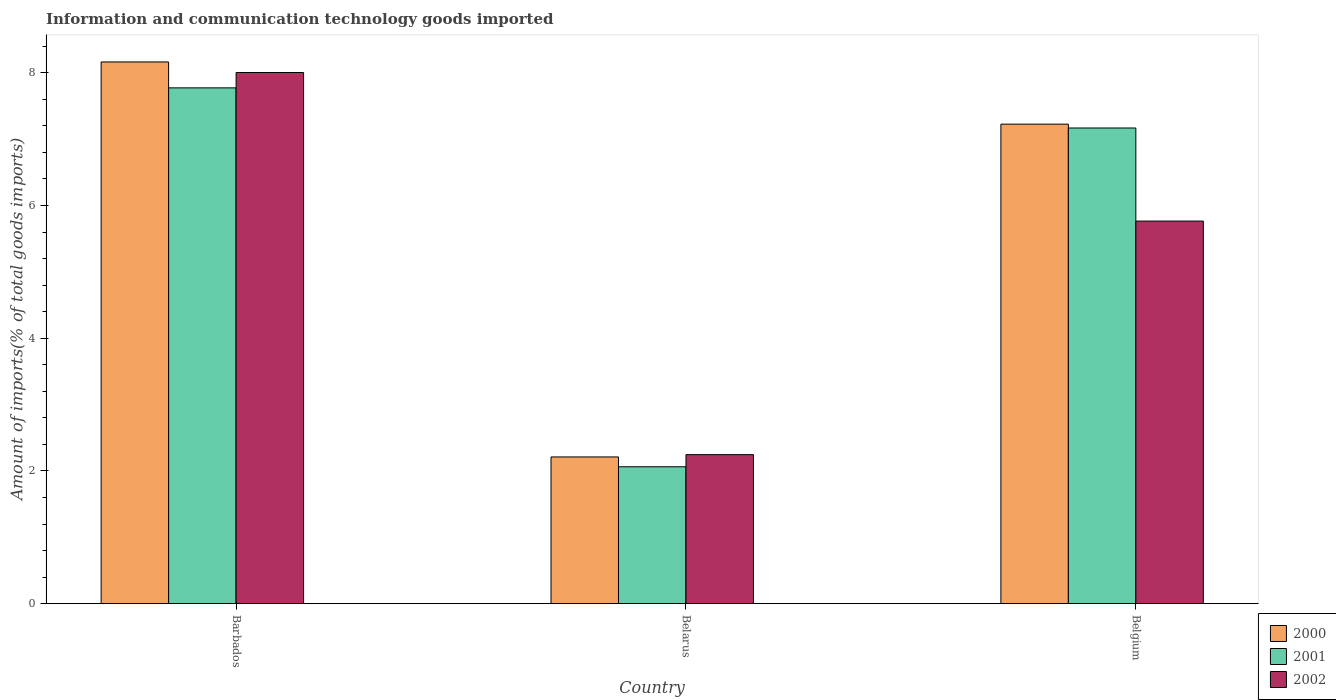How many different coloured bars are there?
Provide a succinct answer. 3. Are the number of bars per tick equal to the number of legend labels?
Offer a terse response. Yes. Are the number of bars on each tick of the X-axis equal?
Your answer should be very brief. Yes. How many bars are there on the 3rd tick from the right?
Give a very brief answer. 3. What is the label of the 1st group of bars from the left?
Give a very brief answer. Barbados. What is the amount of goods imported in 2000 in Belarus?
Give a very brief answer. 2.21. Across all countries, what is the maximum amount of goods imported in 2001?
Offer a very short reply. 7.77. Across all countries, what is the minimum amount of goods imported in 2000?
Give a very brief answer. 2.21. In which country was the amount of goods imported in 2000 maximum?
Your answer should be very brief. Barbados. In which country was the amount of goods imported in 2001 minimum?
Provide a succinct answer. Belarus. What is the total amount of goods imported in 2000 in the graph?
Give a very brief answer. 17.6. What is the difference between the amount of goods imported in 2002 in Barbados and that in Belarus?
Keep it short and to the point. 5.76. What is the difference between the amount of goods imported in 2001 in Belgium and the amount of goods imported in 2002 in Belarus?
Make the answer very short. 4.92. What is the average amount of goods imported in 2001 per country?
Provide a short and direct response. 5.67. What is the difference between the amount of goods imported of/in 2001 and amount of goods imported of/in 2002 in Barbados?
Provide a succinct answer. -0.23. What is the ratio of the amount of goods imported in 2000 in Belarus to that in Belgium?
Your answer should be very brief. 0.31. Is the difference between the amount of goods imported in 2001 in Barbados and Belarus greater than the difference between the amount of goods imported in 2002 in Barbados and Belarus?
Your answer should be very brief. No. What is the difference between the highest and the second highest amount of goods imported in 2000?
Your response must be concise. 5.95. What is the difference between the highest and the lowest amount of goods imported in 2001?
Provide a succinct answer. 5.71. Is the sum of the amount of goods imported in 2002 in Barbados and Belgium greater than the maximum amount of goods imported in 2000 across all countries?
Your answer should be very brief. Yes. What does the 2nd bar from the left in Belgium represents?
Keep it short and to the point. 2001. Is it the case that in every country, the sum of the amount of goods imported in 2002 and amount of goods imported in 2001 is greater than the amount of goods imported in 2000?
Keep it short and to the point. Yes. How many bars are there?
Offer a very short reply. 9. Are all the bars in the graph horizontal?
Make the answer very short. No. How many countries are there in the graph?
Make the answer very short. 3. Does the graph contain any zero values?
Offer a very short reply. No. Does the graph contain grids?
Your answer should be very brief. No. Where does the legend appear in the graph?
Your response must be concise. Bottom right. How many legend labels are there?
Give a very brief answer. 3. How are the legend labels stacked?
Provide a succinct answer. Vertical. What is the title of the graph?
Provide a succinct answer. Information and communication technology goods imported. What is the label or title of the X-axis?
Ensure brevity in your answer.  Country. What is the label or title of the Y-axis?
Your answer should be very brief. Amount of imports(% of total goods imports). What is the Amount of imports(% of total goods imports) of 2000 in Barbados?
Keep it short and to the point. 8.16. What is the Amount of imports(% of total goods imports) in 2001 in Barbados?
Provide a succinct answer. 7.77. What is the Amount of imports(% of total goods imports) in 2002 in Barbados?
Make the answer very short. 8. What is the Amount of imports(% of total goods imports) of 2000 in Belarus?
Ensure brevity in your answer.  2.21. What is the Amount of imports(% of total goods imports) in 2001 in Belarus?
Offer a terse response. 2.06. What is the Amount of imports(% of total goods imports) in 2002 in Belarus?
Provide a succinct answer. 2.25. What is the Amount of imports(% of total goods imports) in 2000 in Belgium?
Your response must be concise. 7.23. What is the Amount of imports(% of total goods imports) of 2001 in Belgium?
Make the answer very short. 7.17. What is the Amount of imports(% of total goods imports) in 2002 in Belgium?
Keep it short and to the point. 5.76. Across all countries, what is the maximum Amount of imports(% of total goods imports) in 2000?
Offer a terse response. 8.16. Across all countries, what is the maximum Amount of imports(% of total goods imports) of 2001?
Provide a succinct answer. 7.77. Across all countries, what is the maximum Amount of imports(% of total goods imports) in 2002?
Ensure brevity in your answer.  8. Across all countries, what is the minimum Amount of imports(% of total goods imports) of 2000?
Provide a succinct answer. 2.21. Across all countries, what is the minimum Amount of imports(% of total goods imports) in 2001?
Make the answer very short. 2.06. Across all countries, what is the minimum Amount of imports(% of total goods imports) in 2002?
Offer a very short reply. 2.25. What is the total Amount of imports(% of total goods imports) in 2000 in the graph?
Give a very brief answer. 17.6. What is the total Amount of imports(% of total goods imports) in 2001 in the graph?
Provide a short and direct response. 17. What is the total Amount of imports(% of total goods imports) in 2002 in the graph?
Ensure brevity in your answer.  16.01. What is the difference between the Amount of imports(% of total goods imports) in 2000 in Barbados and that in Belarus?
Offer a terse response. 5.95. What is the difference between the Amount of imports(% of total goods imports) of 2001 in Barbados and that in Belarus?
Offer a terse response. 5.71. What is the difference between the Amount of imports(% of total goods imports) in 2002 in Barbados and that in Belarus?
Provide a succinct answer. 5.76. What is the difference between the Amount of imports(% of total goods imports) in 2000 in Barbados and that in Belgium?
Your answer should be compact. 0.94. What is the difference between the Amount of imports(% of total goods imports) of 2001 in Barbados and that in Belgium?
Your answer should be compact. 0.6. What is the difference between the Amount of imports(% of total goods imports) in 2002 in Barbados and that in Belgium?
Provide a short and direct response. 2.24. What is the difference between the Amount of imports(% of total goods imports) of 2000 in Belarus and that in Belgium?
Give a very brief answer. -5.01. What is the difference between the Amount of imports(% of total goods imports) in 2001 in Belarus and that in Belgium?
Provide a short and direct response. -5.11. What is the difference between the Amount of imports(% of total goods imports) of 2002 in Belarus and that in Belgium?
Provide a short and direct response. -3.52. What is the difference between the Amount of imports(% of total goods imports) of 2000 in Barbados and the Amount of imports(% of total goods imports) of 2001 in Belarus?
Provide a short and direct response. 6.1. What is the difference between the Amount of imports(% of total goods imports) in 2000 in Barbados and the Amount of imports(% of total goods imports) in 2002 in Belarus?
Your answer should be compact. 5.92. What is the difference between the Amount of imports(% of total goods imports) of 2001 in Barbados and the Amount of imports(% of total goods imports) of 2002 in Belarus?
Provide a succinct answer. 5.53. What is the difference between the Amount of imports(% of total goods imports) in 2000 in Barbados and the Amount of imports(% of total goods imports) in 2001 in Belgium?
Provide a short and direct response. 1. What is the difference between the Amount of imports(% of total goods imports) of 2000 in Barbados and the Amount of imports(% of total goods imports) of 2002 in Belgium?
Provide a short and direct response. 2.4. What is the difference between the Amount of imports(% of total goods imports) in 2001 in Barbados and the Amount of imports(% of total goods imports) in 2002 in Belgium?
Your response must be concise. 2.01. What is the difference between the Amount of imports(% of total goods imports) in 2000 in Belarus and the Amount of imports(% of total goods imports) in 2001 in Belgium?
Your answer should be very brief. -4.96. What is the difference between the Amount of imports(% of total goods imports) of 2000 in Belarus and the Amount of imports(% of total goods imports) of 2002 in Belgium?
Your answer should be compact. -3.55. What is the difference between the Amount of imports(% of total goods imports) of 2001 in Belarus and the Amount of imports(% of total goods imports) of 2002 in Belgium?
Your answer should be very brief. -3.7. What is the average Amount of imports(% of total goods imports) of 2000 per country?
Provide a succinct answer. 5.87. What is the average Amount of imports(% of total goods imports) of 2001 per country?
Ensure brevity in your answer.  5.67. What is the average Amount of imports(% of total goods imports) of 2002 per country?
Your response must be concise. 5.34. What is the difference between the Amount of imports(% of total goods imports) in 2000 and Amount of imports(% of total goods imports) in 2001 in Barbados?
Your answer should be compact. 0.39. What is the difference between the Amount of imports(% of total goods imports) in 2000 and Amount of imports(% of total goods imports) in 2002 in Barbados?
Give a very brief answer. 0.16. What is the difference between the Amount of imports(% of total goods imports) in 2001 and Amount of imports(% of total goods imports) in 2002 in Barbados?
Offer a very short reply. -0.23. What is the difference between the Amount of imports(% of total goods imports) of 2000 and Amount of imports(% of total goods imports) of 2001 in Belarus?
Offer a terse response. 0.15. What is the difference between the Amount of imports(% of total goods imports) of 2000 and Amount of imports(% of total goods imports) of 2002 in Belarus?
Provide a short and direct response. -0.03. What is the difference between the Amount of imports(% of total goods imports) in 2001 and Amount of imports(% of total goods imports) in 2002 in Belarus?
Provide a succinct answer. -0.18. What is the difference between the Amount of imports(% of total goods imports) of 2000 and Amount of imports(% of total goods imports) of 2001 in Belgium?
Offer a terse response. 0.06. What is the difference between the Amount of imports(% of total goods imports) of 2000 and Amount of imports(% of total goods imports) of 2002 in Belgium?
Offer a terse response. 1.46. What is the difference between the Amount of imports(% of total goods imports) of 2001 and Amount of imports(% of total goods imports) of 2002 in Belgium?
Your answer should be compact. 1.4. What is the ratio of the Amount of imports(% of total goods imports) of 2000 in Barbados to that in Belarus?
Keep it short and to the point. 3.69. What is the ratio of the Amount of imports(% of total goods imports) of 2001 in Barbados to that in Belarus?
Keep it short and to the point. 3.77. What is the ratio of the Amount of imports(% of total goods imports) of 2002 in Barbados to that in Belarus?
Your answer should be very brief. 3.56. What is the ratio of the Amount of imports(% of total goods imports) in 2000 in Barbados to that in Belgium?
Your answer should be very brief. 1.13. What is the ratio of the Amount of imports(% of total goods imports) in 2001 in Barbados to that in Belgium?
Provide a short and direct response. 1.08. What is the ratio of the Amount of imports(% of total goods imports) in 2002 in Barbados to that in Belgium?
Your answer should be compact. 1.39. What is the ratio of the Amount of imports(% of total goods imports) in 2000 in Belarus to that in Belgium?
Provide a short and direct response. 0.31. What is the ratio of the Amount of imports(% of total goods imports) of 2001 in Belarus to that in Belgium?
Ensure brevity in your answer.  0.29. What is the ratio of the Amount of imports(% of total goods imports) of 2002 in Belarus to that in Belgium?
Make the answer very short. 0.39. What is the difference between the highest and the second highest Amount of imports(% of total goods imports) in 2000?
Your answer should be compact. 0.94. What is the difference between the highest and the second highest Amount of imports(% of total goods imports) of 2001?
Offer a terse response. 0.6. What is the difference between the highest and the second highest Amount of imports(% of total goods imports) in 2002?
Offer a terse response. 2.24. What is the difference between the highest and the lowest Amount of imports(% of total goods imports) of 2000?
Your answer should be compact. 5.95. What is the difference between the highest and the lowest Amount of imports(% of total goods imports) in 2001?
Provide a short and direct response. 5.71. What is the difference between the highest and the lowest Amount of imports(% of total goods imports) of 2002?
Give a very brief answer. 5.76. 